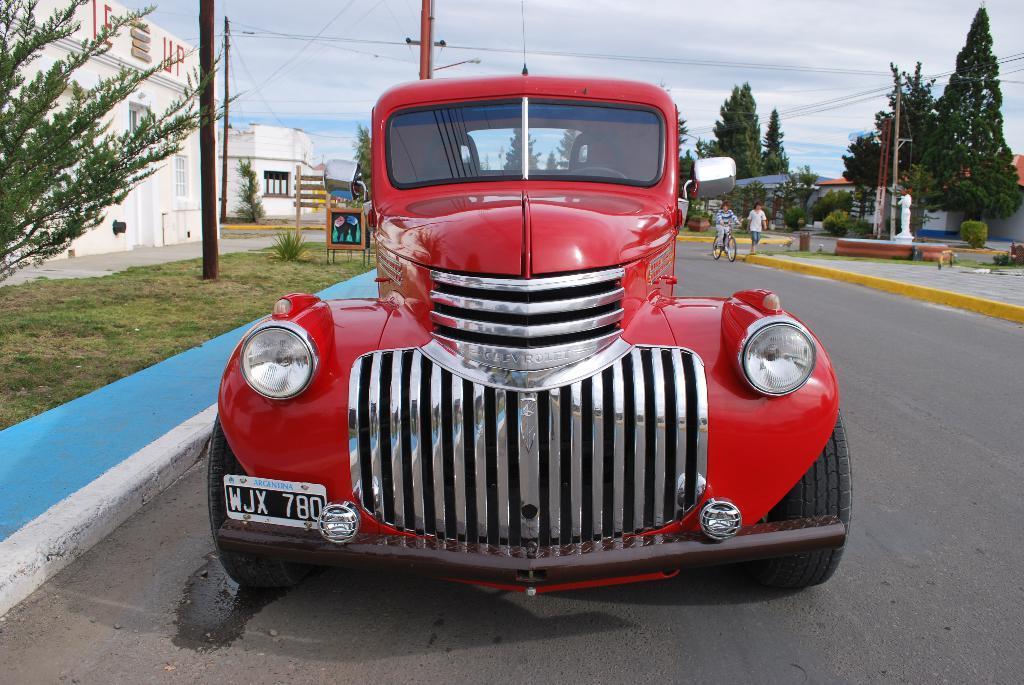Please provide a concise description of this image. Vehicle is on the road. Background there are trees, buildings, people, current poles and plants. Sky is cloudy. 